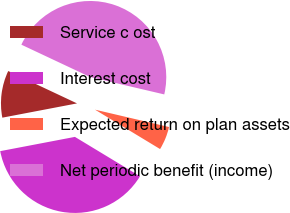Convert chart. <chart><loc_0><loc_0><loc_500><loc_500><pie_chart><fcel>Service c ost<fcel>Interest cost<fcel>Expected return on plan assets<fcel>Net periodic benefit (income)<nl><fcel>10.0%<fcel>38.33%<fcel>5.0%<fcel>46.67%<nl></chart> 